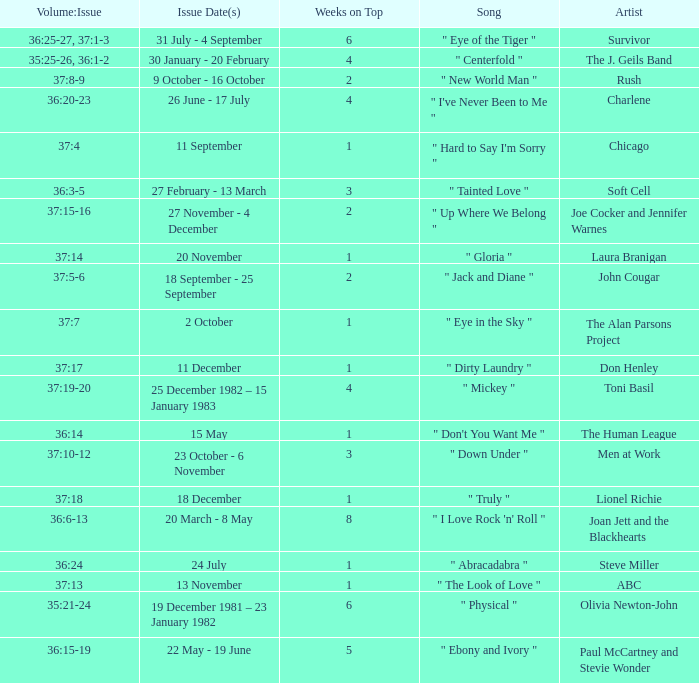Which Issue Date(s) has an Artist of men at work? 23 October - 6 November. 